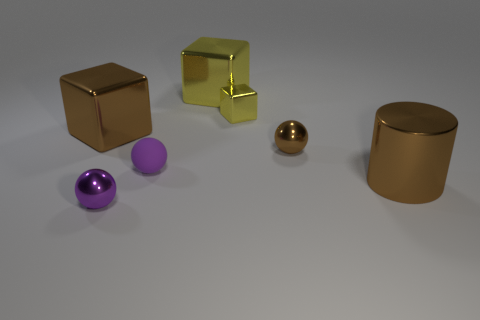How many other objects are the same size as the purple metal thing?
Offer a very short reply. 3. What is the material of the sphere that is both to the right of the purple metallic ball and to the left of the big yellow shiny block?
Your answer should be compact. Rubber. Do the brown shiny thing that is in front of the purple matte thing and the tiny brown object have the same size?
Provide a succinct answer. No. What number of tiny metallic things are behind the big cylinder and in front of the brown sphere?
Give a very brief answer. 0. There is a metallic sphere that is behind the thing that is on the right side of the small brown metal ball; what number of brown things are to the left of it?
Keep it short and to the point. 1. What size is the metallic block that is the same color as the big cylinder?
Your answer should be very brief. Large. The tiny brown metal object has what shape?
Your answer should be compact. Sphere. What number of large cyan cylinders are the same material as the big yellow object?
Offer a terse response. 0. What is the color of the other large block that is made of the same material as the big yellow cube?
Your answer should be compact. Brown. There is a brown metallic cylinder; does it have the same size as the metal object in front of the brown metal cylinder?
Make the answer very short. No. 